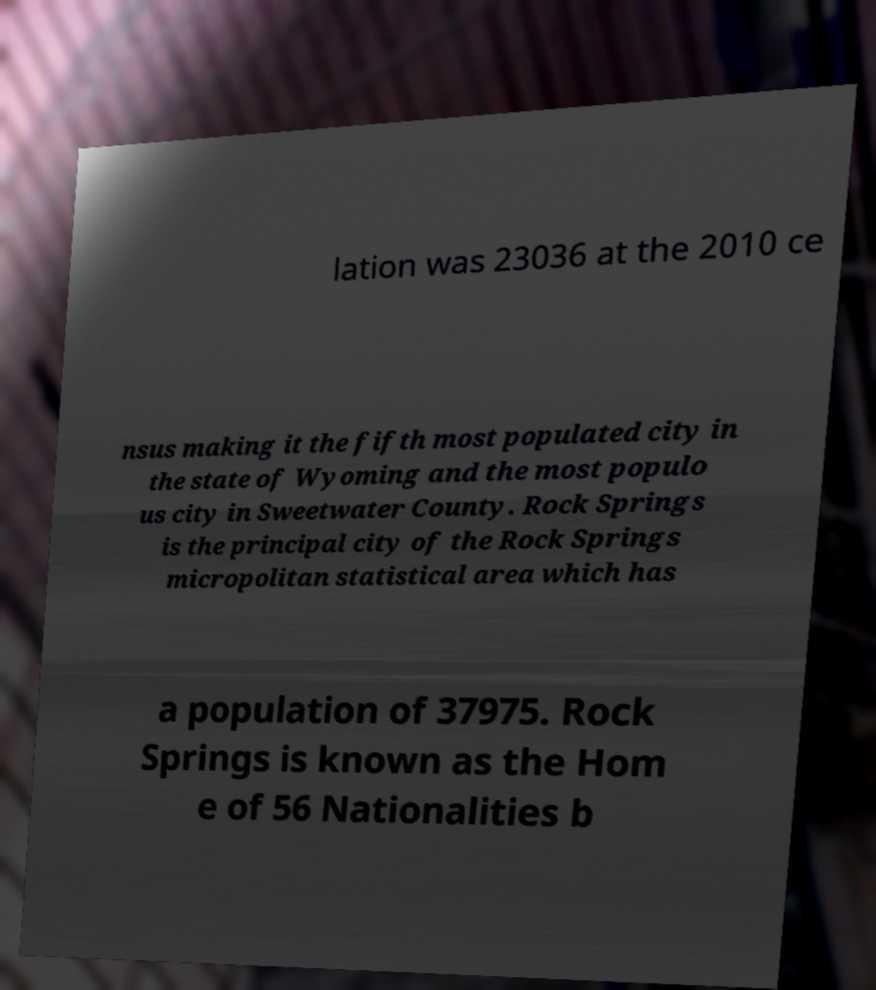For documentation purposes, I need the text within this image transcribed. Could you provide that? lation was 23036 at the 2010 ce nsus making it the fifth most populated city in the state of Wyoming and the most populo us city in Sweetwater County. Rock Springs is the principal city of the Rock Springs micropolitan statistical area which has a population of 37975. Rock Springs is known as the Hom e of 56 Nationalities b 